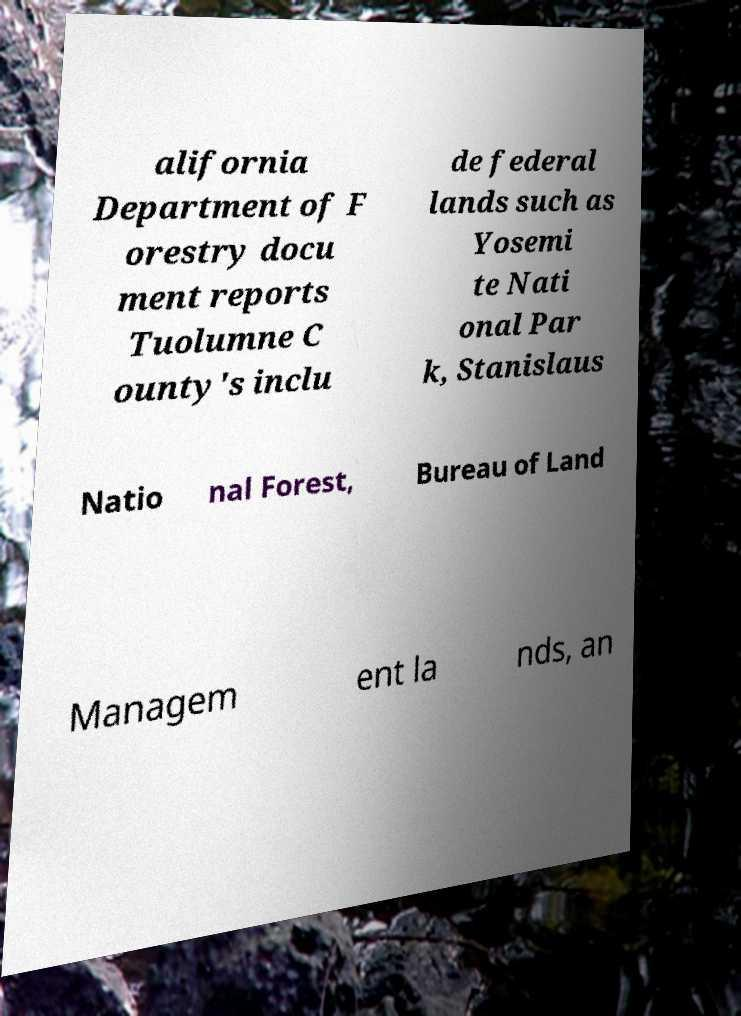Please read and relay the text visible in this image. What does it say? alifornia Department of F orestry docu ment reports Tuolumne C ounty's inclu de federal lands such as Yosemi te Nati onal Par k, Stanislaus Natio nal Forest, Bureau of Land Managem ent la nds, an 